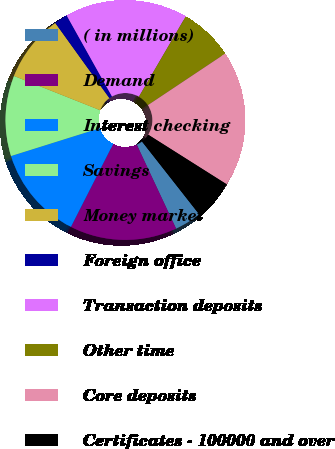<chart> <loc_0><loc_0><loc_500><loc_500><pie_chart><fcel>( in millions)<fcel>Demand<fcel>Interest checking<fcel>Savings<fcel>Money market<fcel>Foreign office<fcel>Transaction deposits<fcel>Other time<fcel>Core deposits<fcel>Certificates - 100000 and over<nl><fcel>3.62%<fcel>14.47%<fcel>12.67%<fcel>10.86%<fcel>9.05%<fcel>1.81%<fcel>16.52%<fcel>7.24%<fcel>18.33%<fcel>5.43%<nl></chart> 